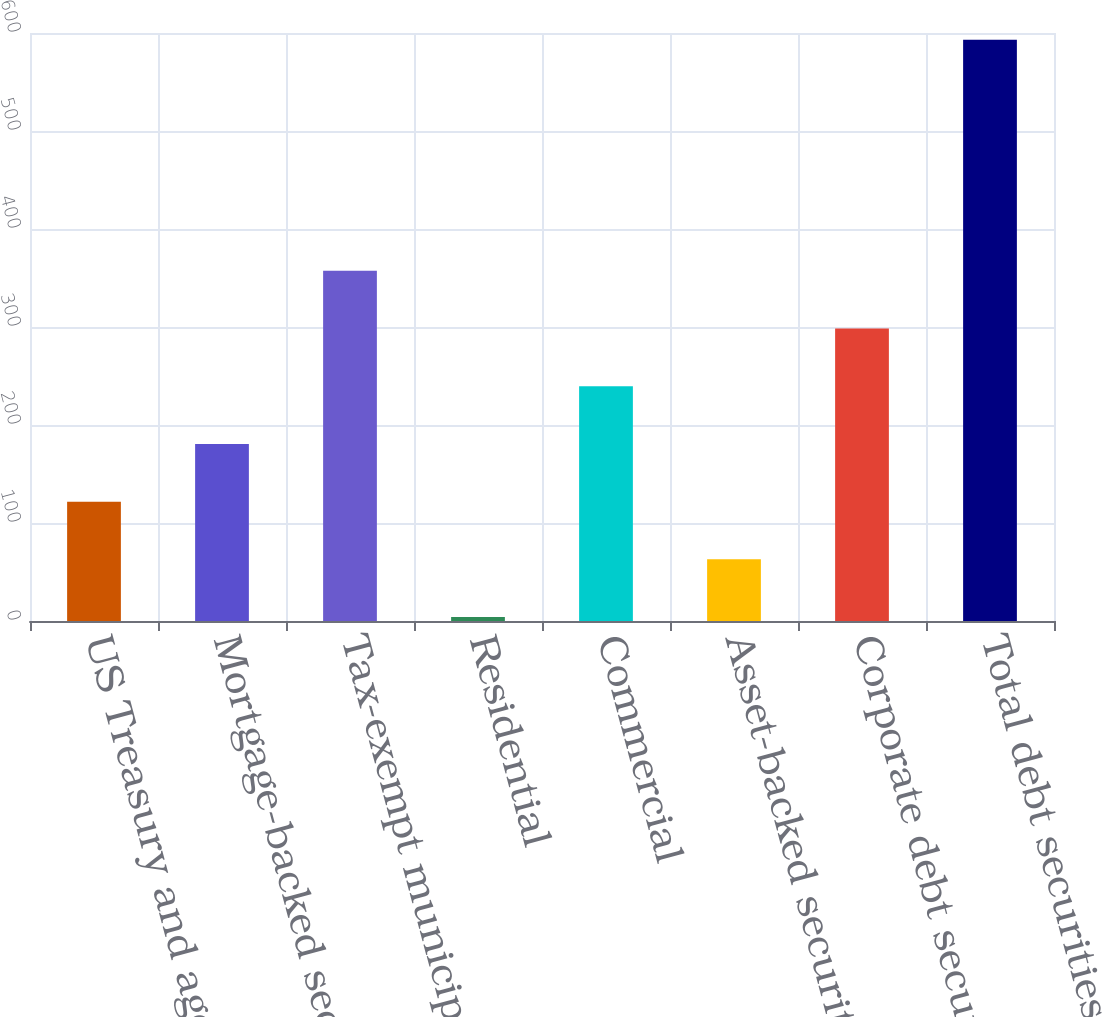Convert chart. <chart><loc_0><loc_0><loc_500><loc_500><bar_chart><fcel>US Treasury and agency<fcel>Mortgage-backed securities<fcel>Tax-exempt municipal<fcel>Residential<fcel>Commercial<fcel>Asset-backed securities<fcel>Corporate debt securities<fcel>Total debt securities<nl><fcel>121.8<fcel>180.7<fcel>357.4<fcel>4<fcel>239.6<fcel>62.9<fcel>298.5<fcel>593<nl></chart> 